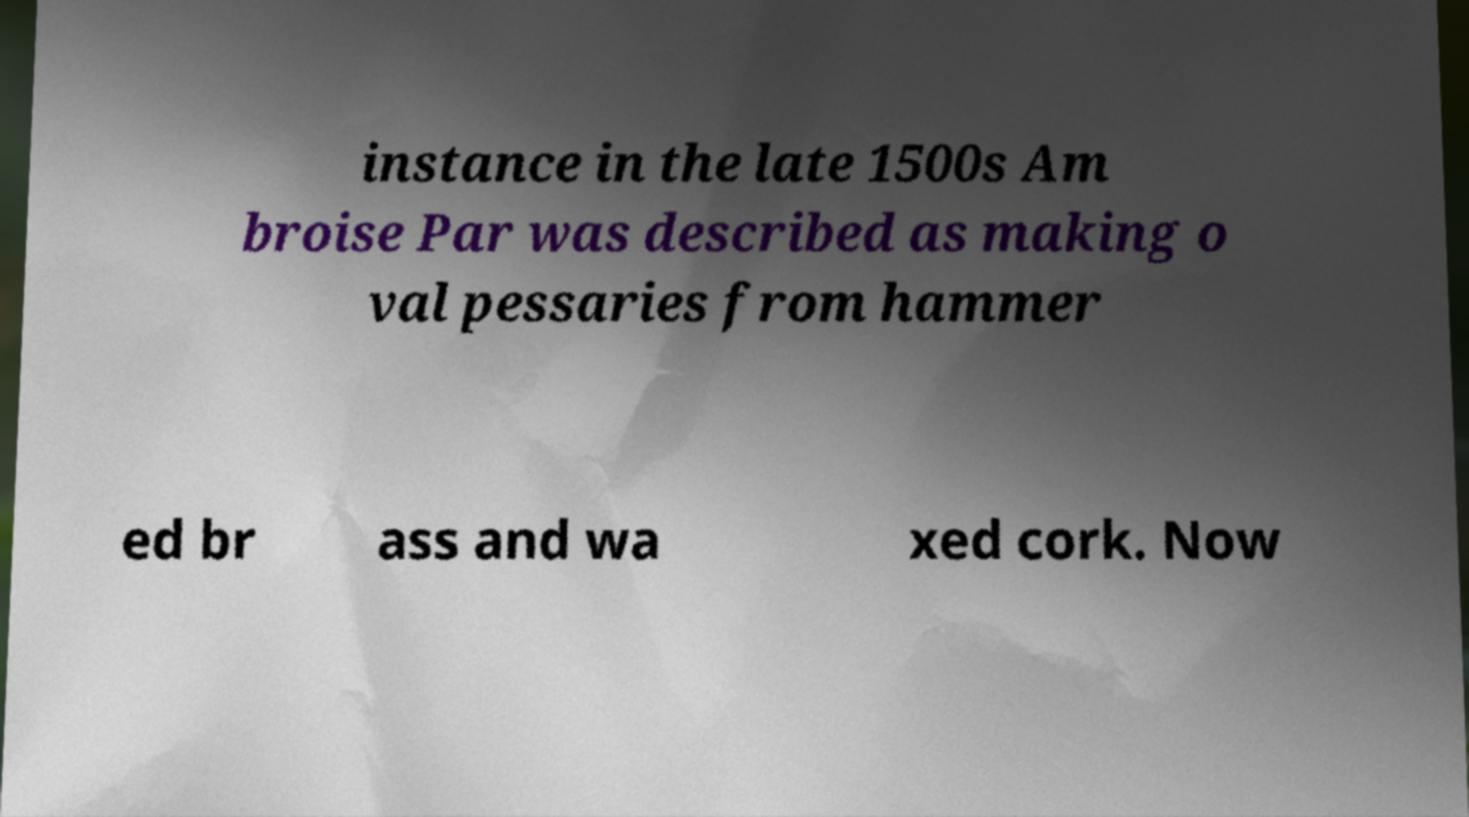Could you extract and type out the text from this image? instance in the late 1500s Am broise Par was described as making o val pessaries from hammer ed br ass and wa xed cork. Now 